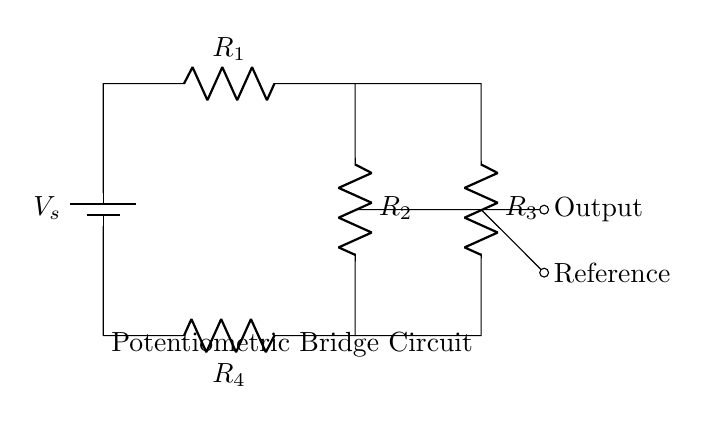What is the type of the circuit shown? The circuit is a potentiometric bridge circuit, which is characterized by its specific arrangement of resistors and the output that allows for precision voltage measurements.
Answer: potentiometric bridge How many resistors are included in the circuit diagram? The circuit has four resistors labeled R1, R2, R3, and R4. Each resistor plays a role in balancing the bridge configuration.
Answer: four What is the purpose of the output in the circuit? The output connects to the measurement device to determine the potential difference across the bridge, which is essential for precision measurement in this type of circuit.
Answer: measurement What could happen if R1 equals R3? If R1 equals R3, the bridge will be balanced, resulting in zero output voltage. This is a critical state for accurate measurements in a potentiometric bridge.
Answer: zero output What does the reference node signify in this circuit? The reference node indicates where the reference voltage is derived for comparison against the output voltage, which is necessary for precise voltage measurements.
Answer: reference voltage Which component provides the supply voltage in the circuit? The battery labeled as Vs provides the supply voltage for the circuit, essential for powering the resistive network and enabling measurements.
Answer: battery What is a typical application for this potentiometric bridge circuit? This circuit is commonly used in laboratory equipment for precise measurements of voltage, often in calibration processes or sensor applications.
Answer: precision measurements 